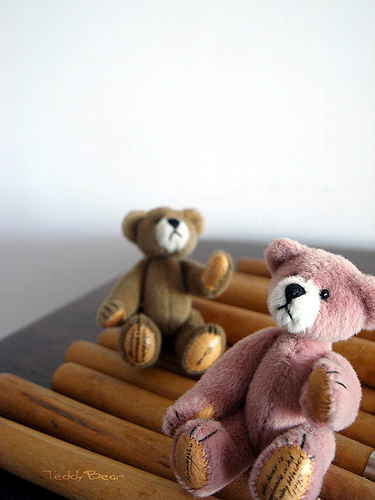Please transcribe the text information in this image. Teddy Bear 